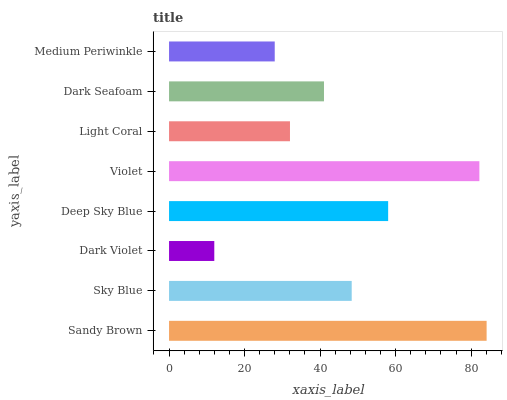Is Dark Violet the minimum?
Answer yes or no. Yes. Is Sandy Brown the maximum?
Answer yes or no. Yes. Is Sky Blue the minimum?
Answer yes or no. No. Is Sky Blue the maximum?
Answer yes or no. No. Is Sandy Brown greater than Sky Blue?
Answer yes or no. Yes. Is Sky Blue less than Sandy Brown?
Answer yes or no. Yes. Is Sky Blue greater than Sandy Brown?
Answer yes or no. No. Is Sandy Brown less than Sky Blue?
Answer yes or no. No. Is Sky Blue the high median?
Answer yes or no. Yes. Is Dark Seafoam the low median?
Answer yes or no. Yes. Is Sandy Brown the high median?
Answer yes or no. No. Is Deep Sky Blue the low median?
Answer yes or no. No. 